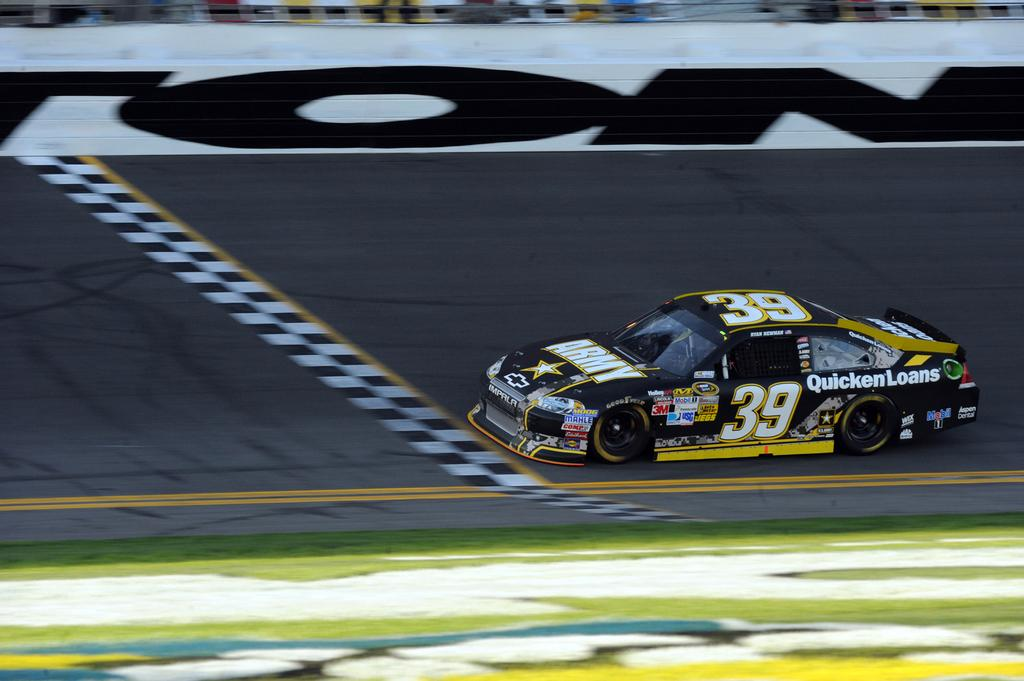What is the main subject of the image? The main subject of the image is a racing car. Where is the racing car located in the image? The racing car is on the road in the image. What type of surface is visible on the ground in the image? There is grass on the ground in the image. Is there any text or branding on the racing car? Yes, there is text on the racing car. What month is it in the image? The month is not mentioned or depicted in the image, so it cannot be determined. Can you smell the exhaust from the racing car in the image? The image is a visual representation, so it is not possible to smell the exhaust from the racing car through the image. 